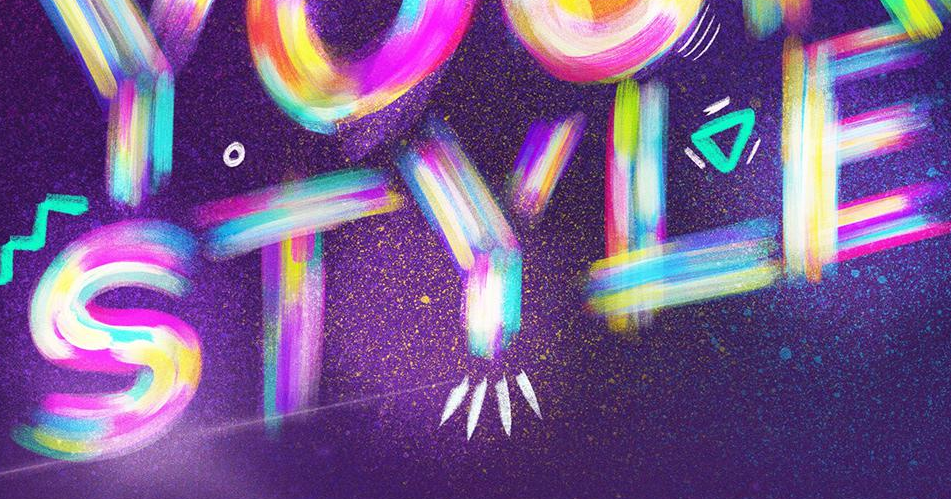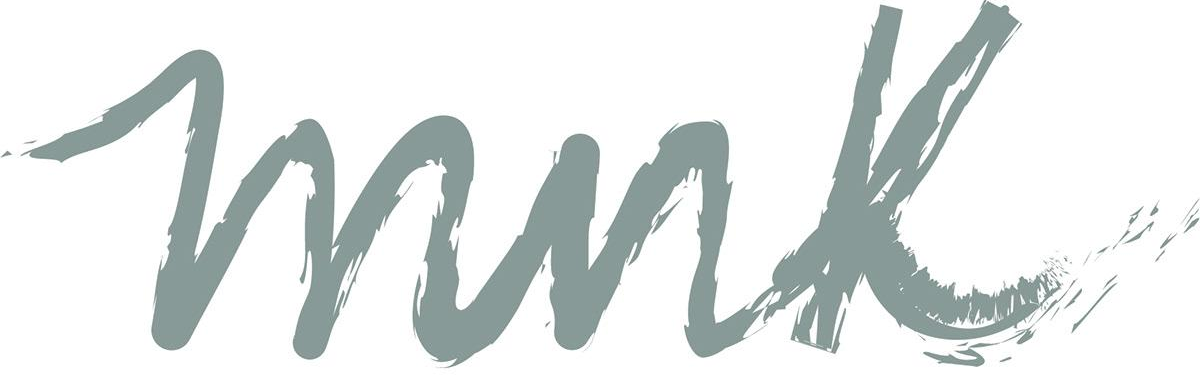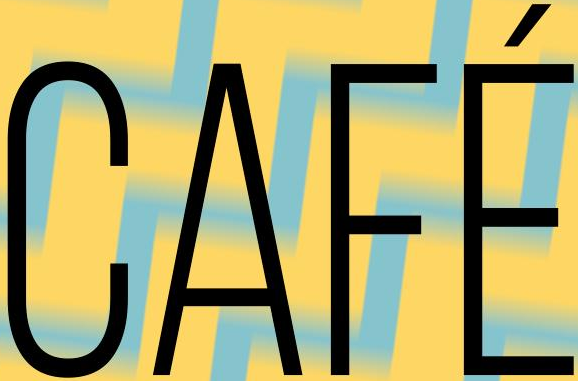What words are shown in these images in order, separated by a semicolon? STYLE; mnk; CAFÉ 